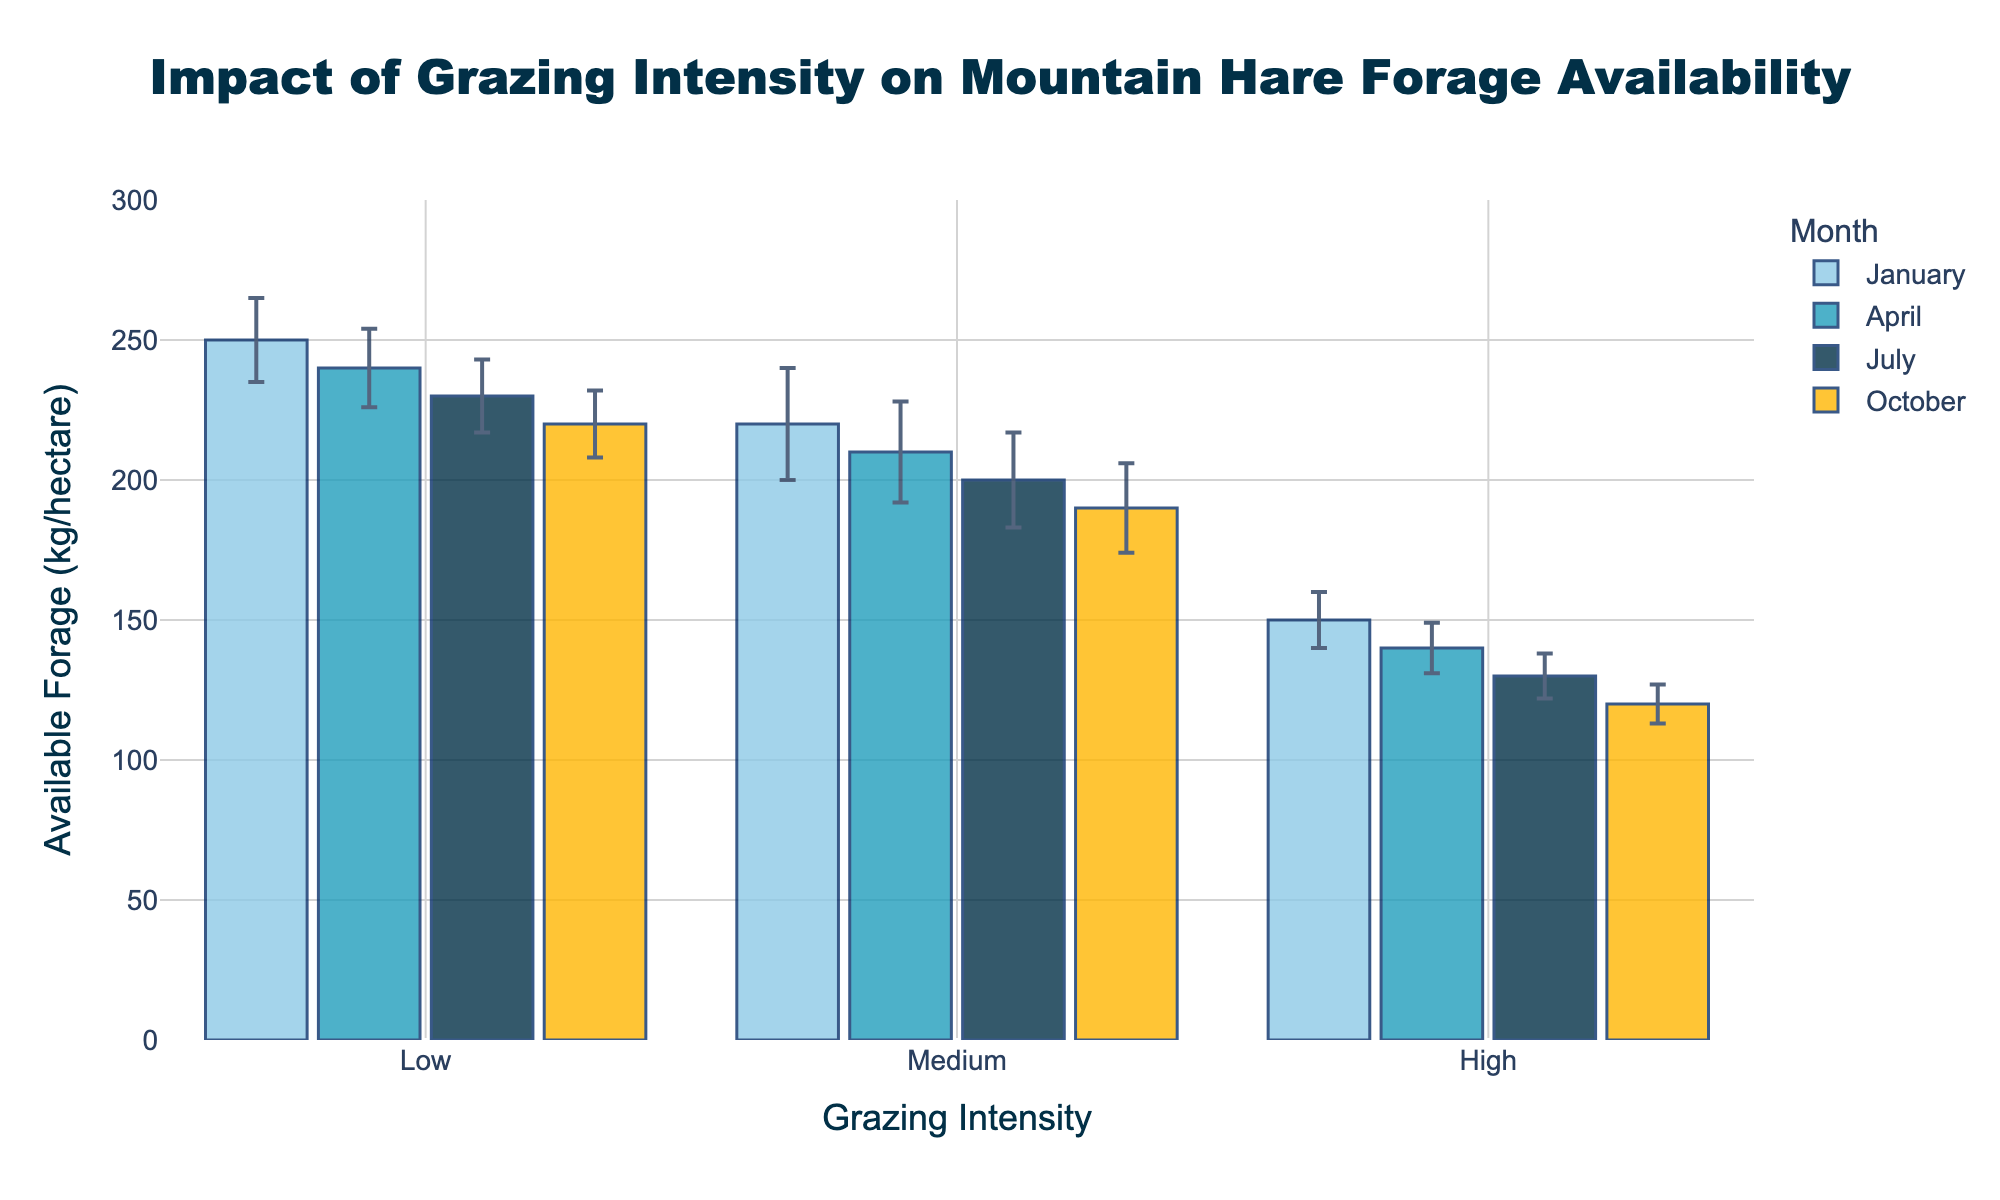what is the title of the figure? The title of the figure is often located at the top and is designed to give a brief description of the data being presented. From this figure, the title reads, "Impact of Grazing Intensity on Mountain Hare Forage Availability"
Answer: Impact of Grazing Intensity on Mountain Hare Forage Availability What are the available forage values for low grazing intensity in each month? To answer this, observe the height of the bars for "Low" grazing intensity in each month. The values are 250 kg/hectare in January, 240 kg/hectare in April, 230 kg/hectare in July, and 220 kg/hectare in October
Answer: 250 (January), 240 (April), 230 (July), 220 (October) How do the available forage values for 'High' grazing intensity compare between January and October? To compare values, note the height of the "High" grazing intensity bars in January and October. January's value is 150 kg/hectare, and October's value is 120 kg/hectare. January has 30 kg/hectare more than October
Answer: January is 30 kg/hectare higher than October Which month shows the highest available forage for 'Medium' grazing intensity, and what is the value? Look at the bars for 'Medium' grazing intensity in each month and find the tallest one. The highest value for 'Medium' grazing intensity is in January, with 220 kg/hectare
Answer: January, 220 kg/hectare What is the range of error bars for 'High' grazing intensity in July? Error bars represent the standard error. In July, the 'High' grazing intensity value is 130 kg/hectare with a standard error of 8. The range is from 130-8 to 130+8, which is 122 to 138 kg/hectare
Answer: 122 to 138 kg/hectare What is the average available forage for 'Low' grazing intensity over all months? Take the values for 'Low' grazing intensity across all months and calculate the average: (250 + 240 + 230 + 220)/4. The sum is 940, so the average is 940/4 = 235 kg/hectare
Answer: 235 kg/hectare How does the available forage vary with grazing intensity in April? To understand the variation, compare the bars in April. 'Low' shows 240 kg/hectare, 'Medium' shows 210 kg/hectare, and 'High' shows 140 kg/hectare. Available forage decreases as grazing intensity increases
Answer: decreases with increasing intensity Which grazing intensity has the smallest standard error in October and what is the value? Observe the error bars for each grazing intensity in October. The 'High' grazing intensity has the smallest standard error of 7
Answer: High, 7 During which month does 'Low' grazing intensity have the smallest value and what is the amount? Examine the 'Low' grazing intensity bars across all months and find the smallest one. The smallest value for 'Low' grazing intensity is in October with 220 kg/hectare
Answer: October, 220 kg/hectare Calculate the total available forage for all grazing intensities combined in July? Sum the values of forage for 'Low', 'Medium', and 'High' grazing intensities in July: 230 + 200 + 130. The total is 560 kg/hectare
Answer: 560 kg/hectare 